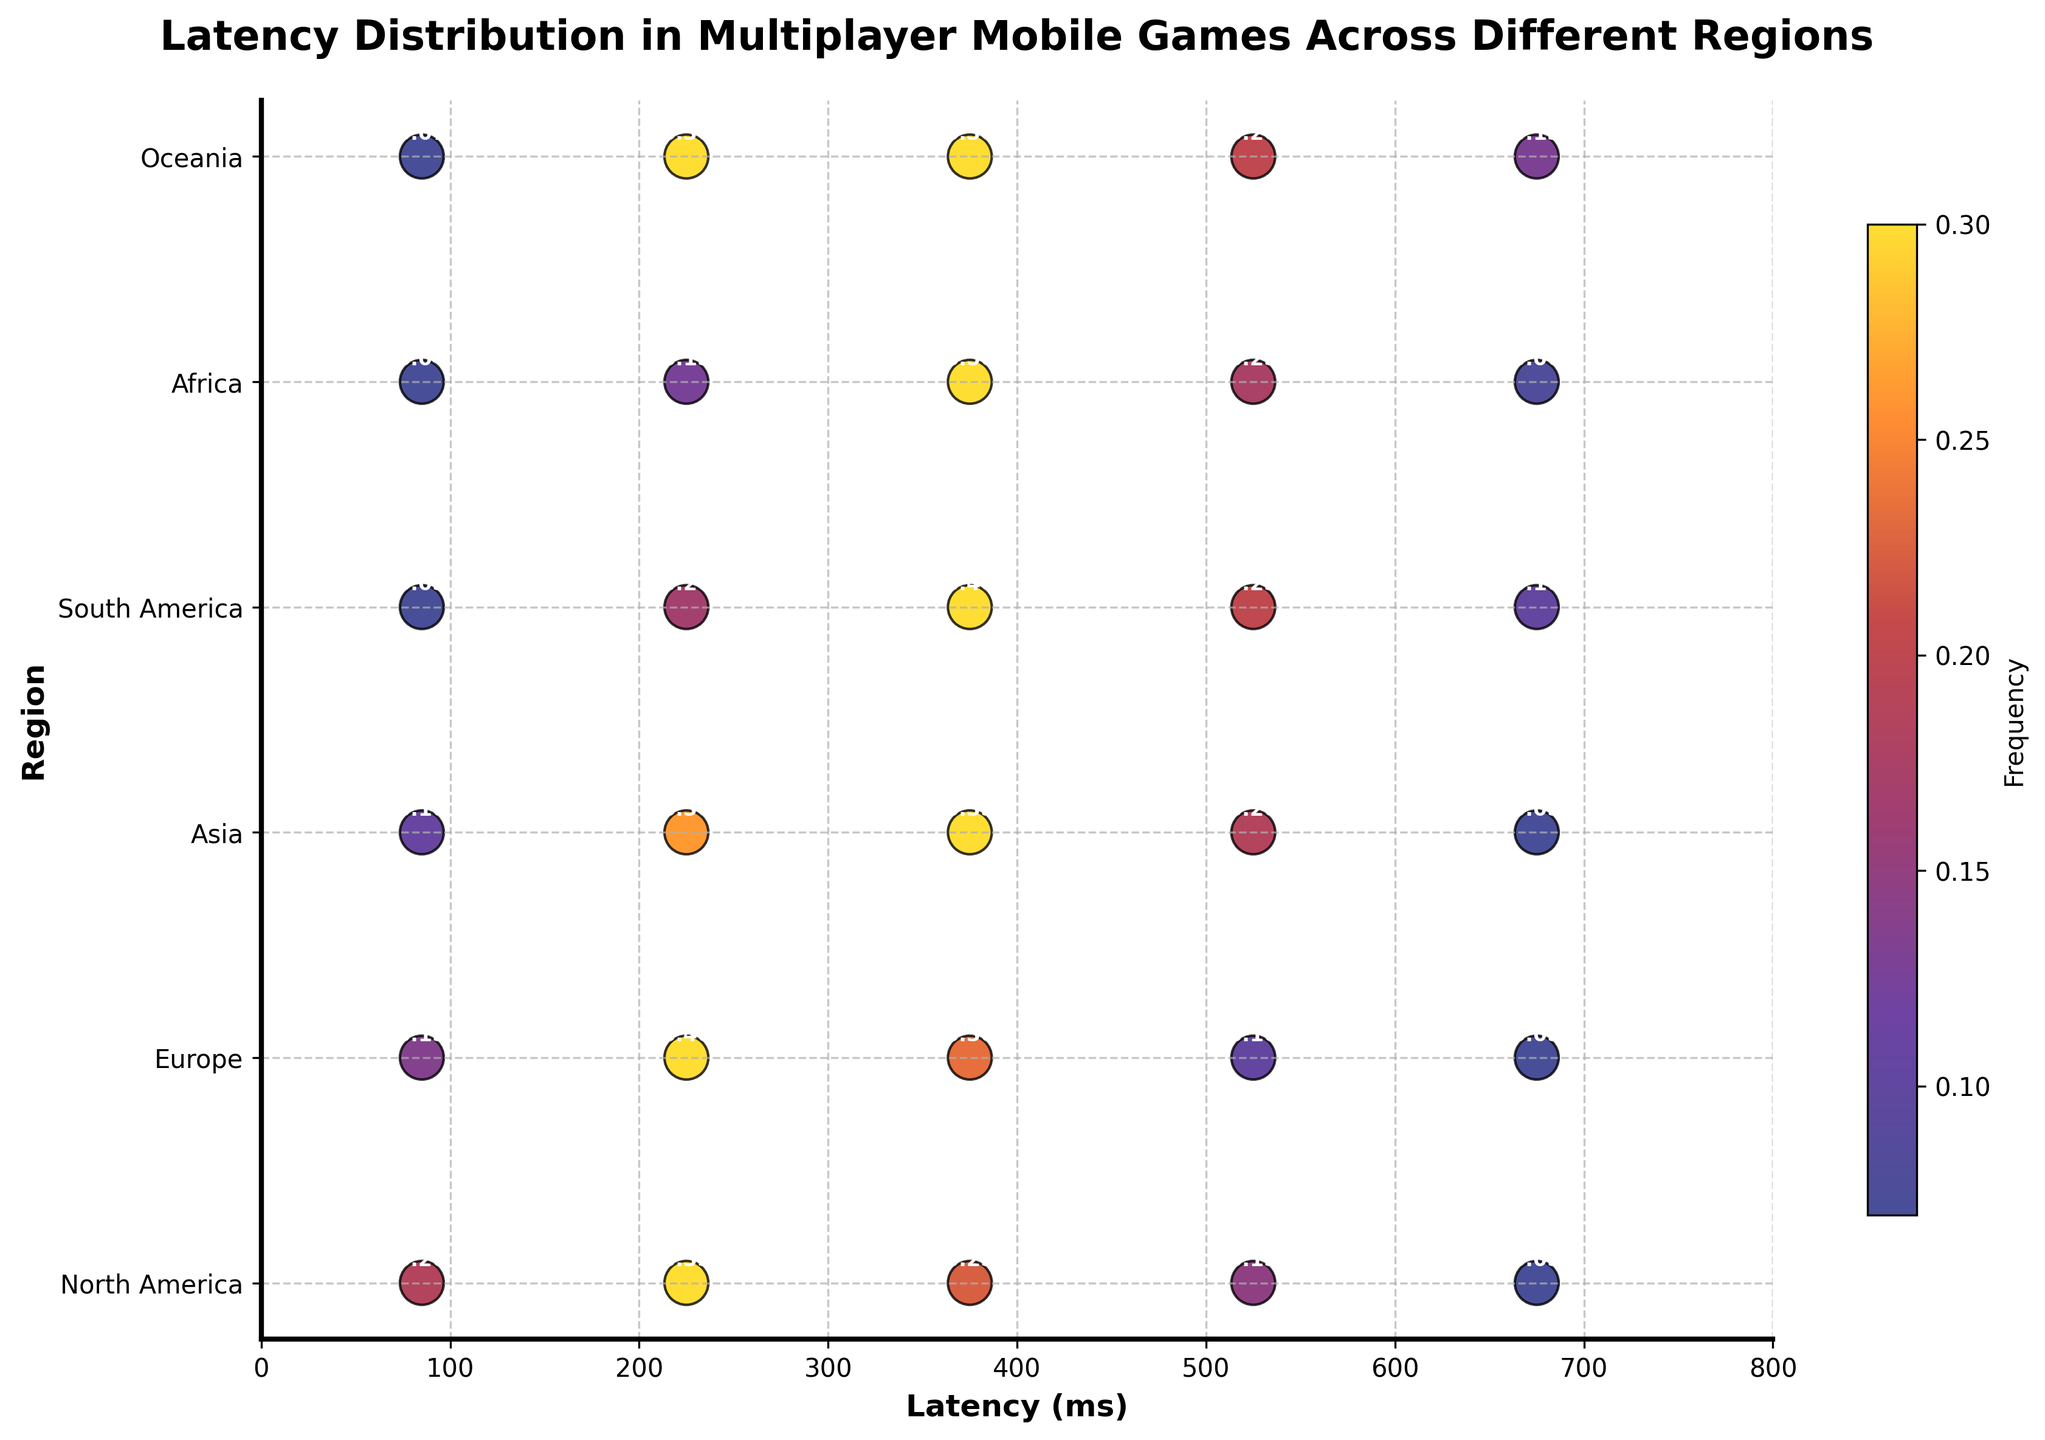What is the title of the figure? The title of the figure is displayed at the top.
Answer: Latency Distribution in Multiplayer Mobile Games Across Different Regions How many latency ranges are shown in the figure? By observing the x-axis labels, we can count the number of distinct latency ranges from 0 to 800 ms.
Answer: 5 Which region has the highest frequency of latency between 300 ms to 450 ms? Look at the regions on the y-axis and find the corresponding frequency values for the 300 ms to 450 ms latency range. Compare the values to see which is highest.
Answer: Africa What is the sum of the frequencies for North America? Add up all the annotated frequency values for North America. The values are: 0.2, 0.35, 0.25, 0.15, 0.05.
Answer: 1.00 Comparing Europe and Asia, which region has a higher frequency for the 150 ms to 300 ms latency range? Identify the frequency values for the 150 ms to 300 ms range for both Europe and Asia, then compare them.
Answer: Europe Which region has the lowest average latency? Calculate the mean latency for each region by considering the latency ranges and frequencies, then find the region with the lowest average. This requires multiple steps, referring to both x-axis and frequencies annotated in the figure: Latency average can be estimated by giving a rough average frequency for each latency range divided by its weight. For North America, it is approx: (0.2*85 + 0.35*225 + 0.25*375 + 0.15*525 + 0.05*675)/1.0 = 273.75 ms. Similar processing for Europe, Asia, South America, Africa, and Oceania yields Europe, which has a lower average latency.
Answer: Europe In which regions does the highest frequency fall within the 300 ms to 450 ms latency range? Identify regions and frequency values for the 300 ms to 450 ms latency range, then compare to find the highest frequency.
Answer: Africa and South America Which region has the most balanced frequency distribution across all latency ranges? Compare the annotated frequency values for each region, finding the one where values don't vary drastically. It requires considering the uniformity of frequency distribution annotations.
Answer: North America What color represents the highest frequency in the figure? Observe the color bar on the right to determine which color corresponds to the highest frequency value.
Answer: Yellow Rank the regions in order of higher to lower frequency for the latency range 450 ms to 600 ms. Extract the annotated frequency values for the 450 ms to 600 ms latency range, then rank the regions based on these values. Values: North America (0.15), Europe (0.1), Asia (0.2), South America (0.25), Africa (0.25), Oceania (0.2).
Answer: South America & Africa > Asia & Oceania > North America > Europe 